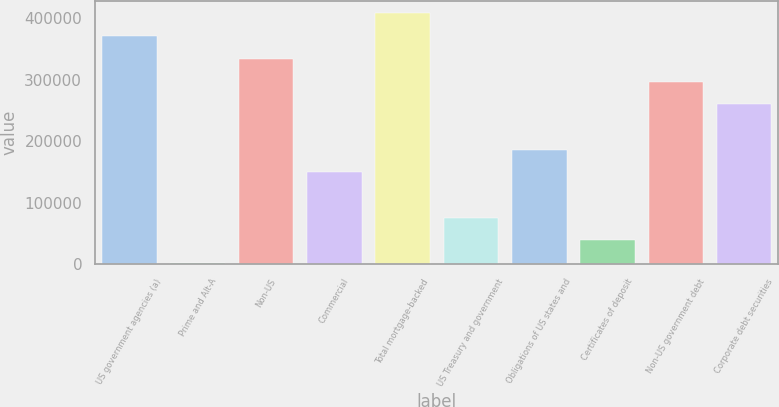<chart> <loc_0><loc_0><loc_500><loc_500><bar_chart><fcel>US government agencies (a)<fcel>Prime and Alt-A<fcel>Non-US<fcel>Commercial<fcel>Total mortgage-backed<fcel>US Treasury and government<fcel>Obligations of US states and<fcel>Certificates of deposit<fcel>Non-US government debt<fcel>Corporate debt securities<nl><fcel>371145<fcel>1933<fcel>334224<fcel>149618<fcel>408066<fcel>75775.4<fcel>186539<fcel>38854.2<fcel>297303<fcel>260381<nl></chart> 